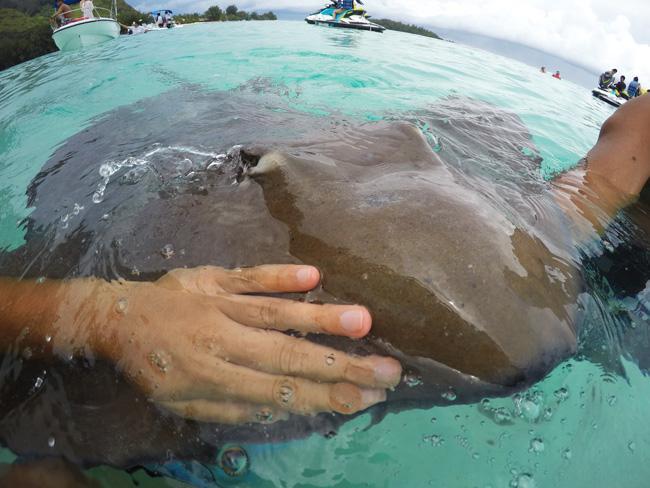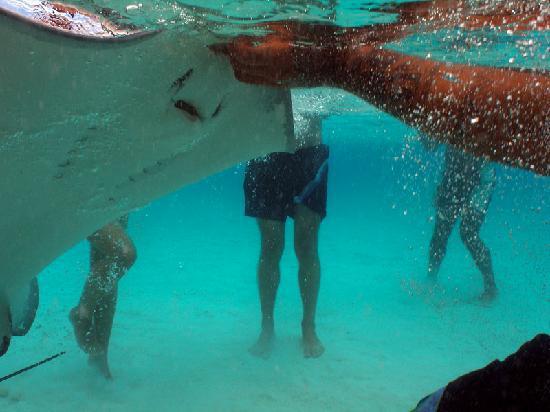The first image is the image on the left, the second image is the image on the right. Evaluate the accuracy of this statement regarding the images: "Hands are extended toward a stingray in at least one image, and an image shows at least two people in the water with a stingray.". Is it true? Answer yes or no. Yes. 